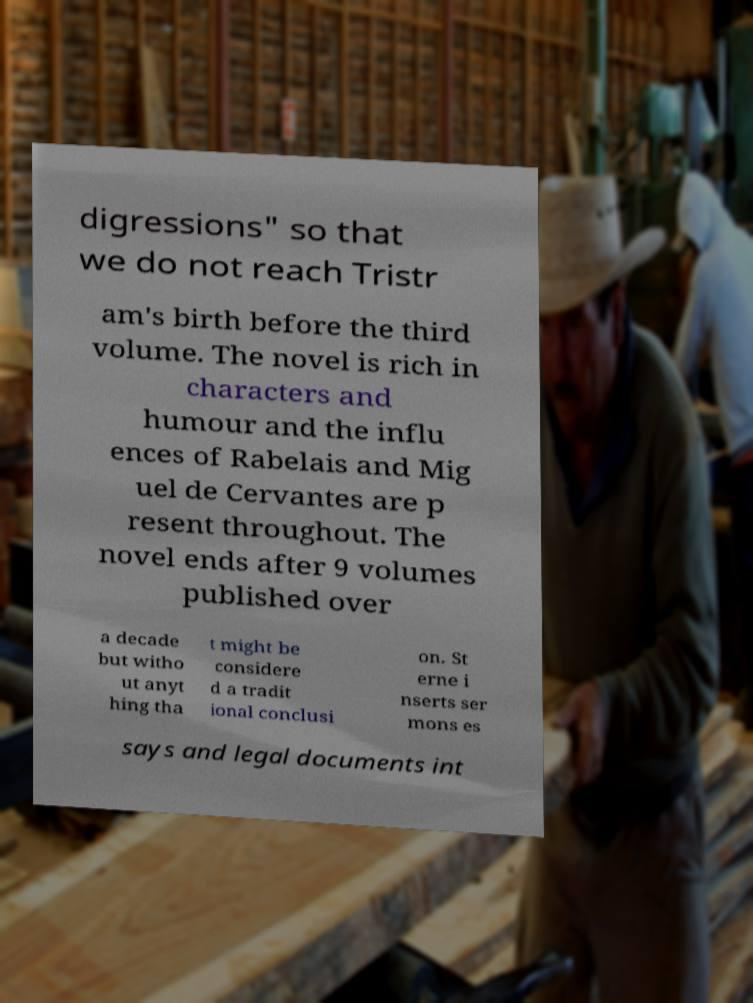Could you assist in decoding the text presented in this image and type it out clearly? digressions" so that we do not reach Tristr am's birth before the third volume. The novel is rich in characters and humour and the influ ences of Rabelais and Mig uel de Cervantes are p resent throughout. The novel ends after 9 volumes published over a decade but witho ut anyt hing tha t might be considere d a tradit ional conclusi on. St erne i nserts ser mons es says and legal documents int 